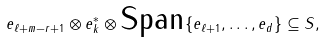Convert formula to latex. <formula><loc_0><loc_0><loc_500><loc_500>e _ { \ell + m - r + 1 } \otimes e ^ { * } _ { k } \otimes \text {Span} \{ e _ { \ell + 1 } , \dots , e _ { d } \} \subseteq S ,</formula> 